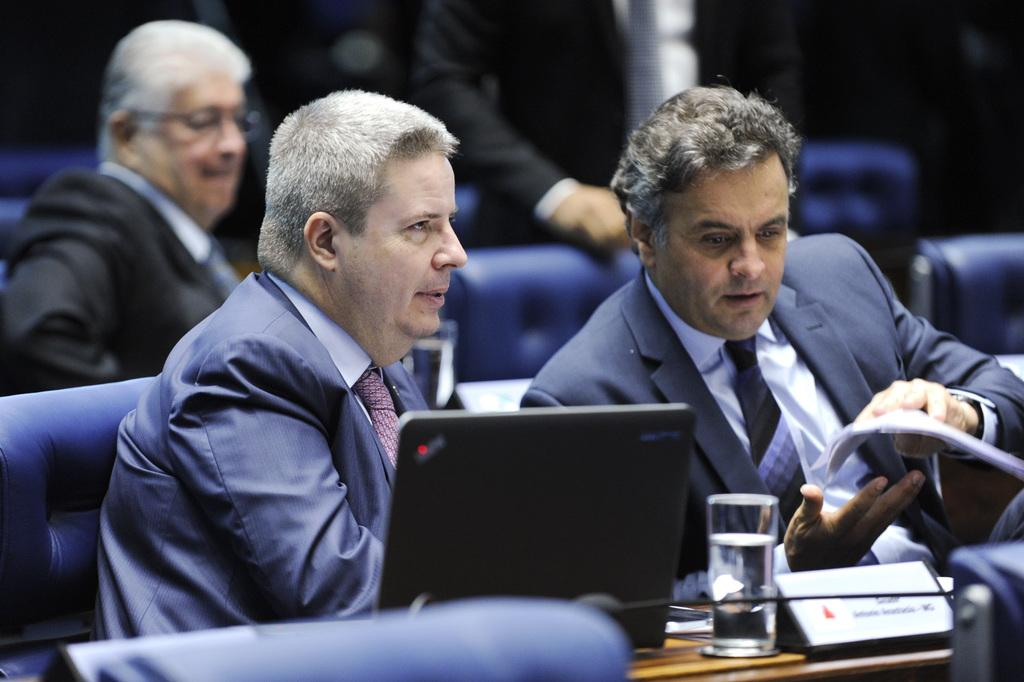What are the persons in the image doing? The persons in the image are sitting on the couches. What objects are placed in front of the persons? Tables are placed in front of the persons. What electronic device can be seen on the table? There is a laptop on the table. What type of drinking vessels are present on the table? Glass tumblers are present on the table. What items might be used for identification purposes in the image? Name boards are visible on the table. What type of flowers can be seen growing out of the laptop in the image? There are no flowers present in the image, and the laptop is not depicted as having any growth or vegetation. 